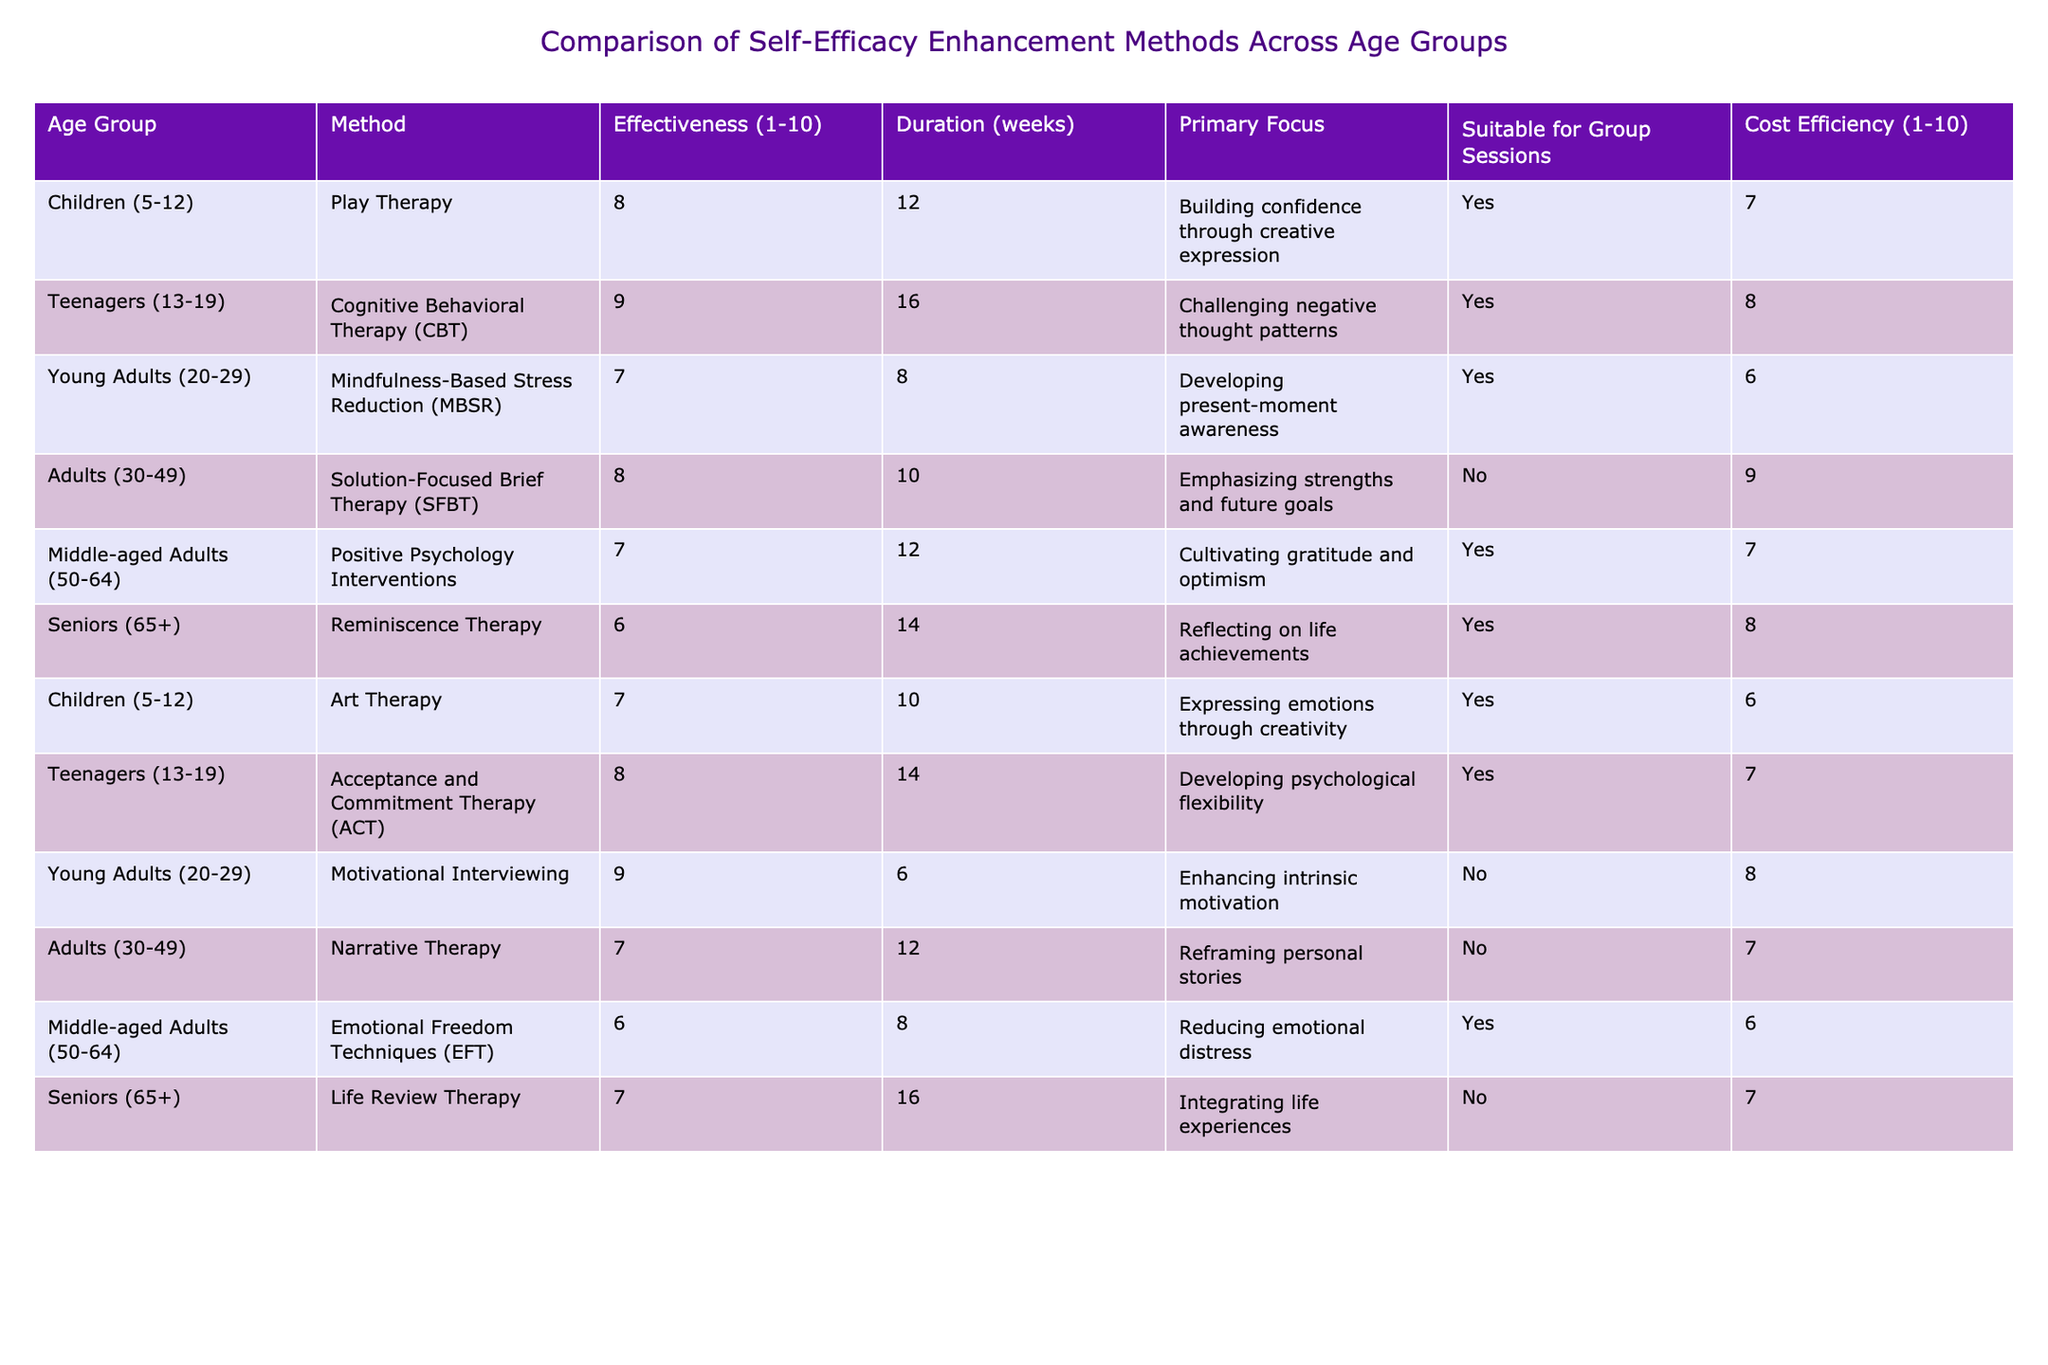What is the effectiveness score of Cognitive Behavioral Therapy for teenagers? The table shows that the effectiveness score for Cognitive Behavioral Therapy (CBT) for the age group of teenagers (13-19) is 9.
Answer: 9 Which method has the highest cost efficiency among middle-aged adults? For middle-aged adults (50-64), the methods listed are Positive Psychology Interventions (cost efficiency 7) and Emotional Freedom Techniques (cost efficiency 6). Positive Psychology Interventions has the highest cost efficiency score of 7.
Answer: 7 Is Solution-Focused Brief Therapy suitable for group sessions? The data indicates that Solution-Focused Brief Therapy (SFBT) for adults (30-49) is marked as "No" under the suitable for group sessions column.
Answer: No What is the average effectiveness score for self-efficacy enhancement methods across seniors? The effectiveness scores for seniors (65+) are as follows: Reminiscence Therapy (6), and Life Review Therapy (7). To calculate the average, we sum these scores: (6 + 7) = 13, then divide by the number of methods: 13/2 = 6.5.
Answer: 6.5 Which age group has the longest duration for mindfulness-based stress reduction? Mindfulness-Based Stress Reduction (MBSR) is listed under young adults (20-29) with a duration of 8 weeks. Therefore, no other age group has MBSR listed since it only appears for young adults. Thus, this question is irrelevant since it may lead to confusion regarding the maximum duration across groups.
Answer: 8 (for young adults) How many methods suitable for group sessions are there for children? The methods for children (5-12) are Play Therapy and Art Therapy, both of which are marked as "Yes" for suitable for group sessions. Therefore, there are two methods suitable for group sessions for this age group.
Answer: 2 What is the primary focus of Acceptance and Commitment Therapy for teenagers? Acceptance and Commitment Therapy (ACT) is listed under teenagers (13-19), with a primary focus on developing psychological flexibility, as stated in the primary focus column of the table.
Answer: Developing psychological flexibility Which age group has the lowest average cost efficiency score? The cost efficiency scores across the groups are as follows: Children (6.5), Teenagers (7.5), Young Adults (7), Adults (8), Middle-aged Adults (6.5), Seniors (7). The average cost efficiency for children and middle-aged adults is the lowest at 6.5. Therefore, we focus on these two groups for the lowest score. Both children and middle-aged adults are equal in having the lowest average.
Answer: Children and Middle-aged Adults (6.5) 